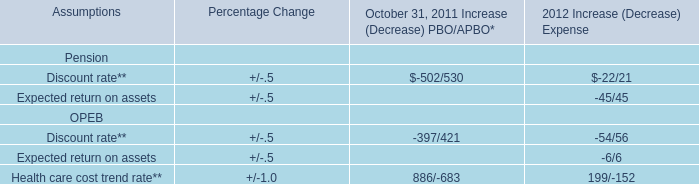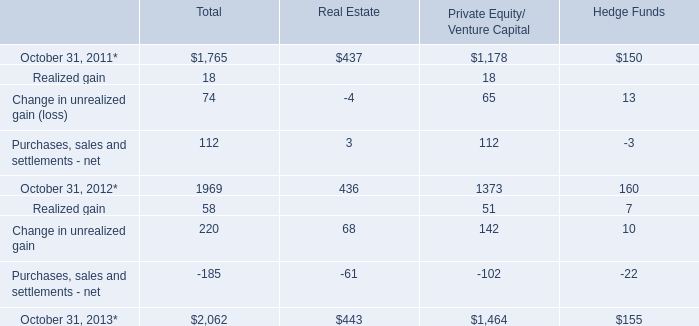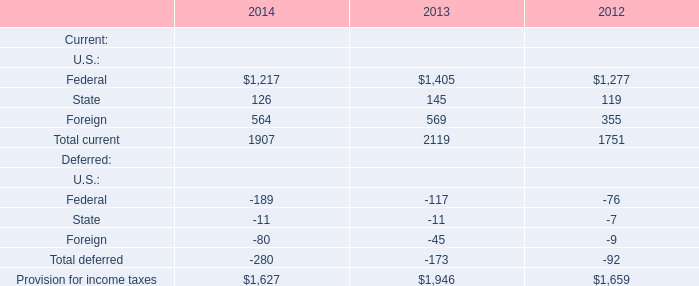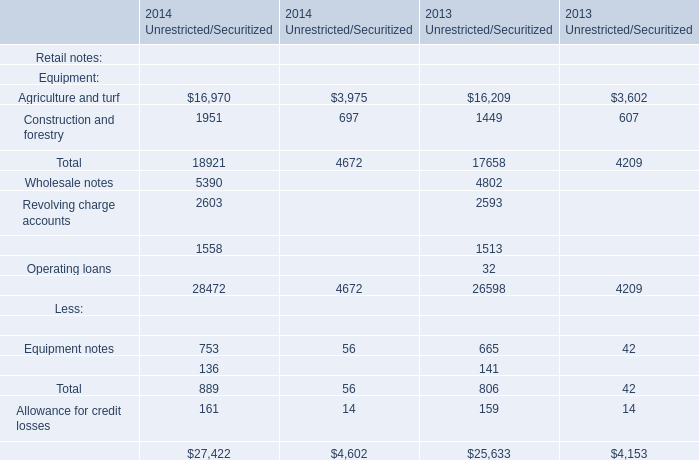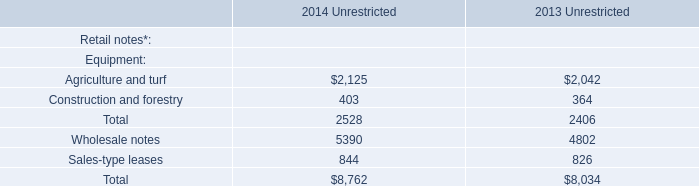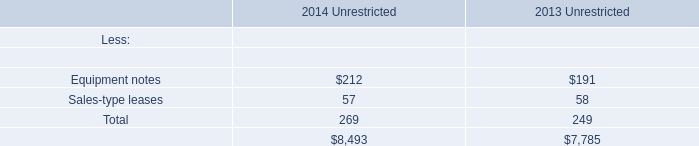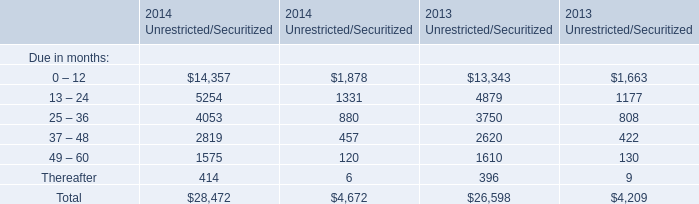What will Due in months(0-12) in Unrestricted reach in 2015 if it continues to grow at its current rate? 
Computations: ((1 + ((14357 - 13343) / 13343)) * 14357)
Answer: 15448.05883. 